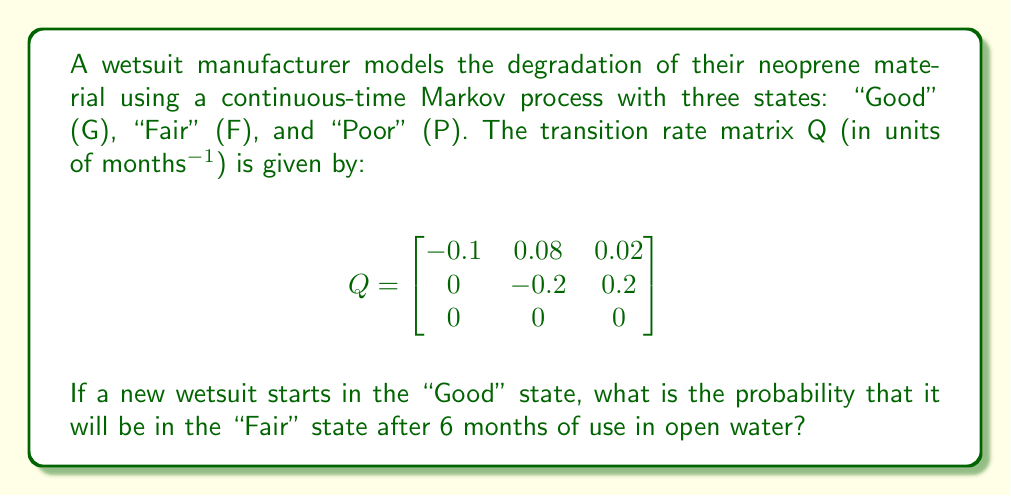Provide a solution to this math problem. To solve this problem, we need to use the continuous-time Markov process transition probability matrix, given by:

$$P(t) = e^{Qt}$$

Where $Q$ is the transition rate matrix and $t$ is the time (in this case, 6 months).

Steps to solve:

1) First, we need to calculate $e^{Qt}$. This can be done using the matrix exponential function or by utilizing eigenvalue decomposition.

2) For simplicity, we'll use a numerical approximation method:
   $$P(t) \approx I + Qt + \frac{(Qt)^2}{2!} + \frac{(Qt)^3}{3!} + ...$$

3) Let's calculate the first few terms:

   $Qt = 6 \cdot \begin{bmatrix}
   -0.1 & 0.08 & 0.02 \\
   0 & -0.2 & 0.2 \\
   0 & 0 & 0
   \end{bmatrix} = \begin{bmatrix}
   -0.6 & 0.48 & 0.12 \\
   0 & -1.2 & 1.2 \\
   0 & 0 & 0
   \end{bmatrix}$

   $(Qt)^2 = \begin{bmatrix}
   0.36 & -0.576 & 0.216 \\
   0 & 1.44 & -1.44 \\
   0 & 0 & 0
   \end{bmatrix}$

   $(Qt)^3 = \begin{bmatrix}
   -0.216 & 0.5184 & -0.3024 \\
   0 & -1.728 & 1.728 \\
   0 & 0 & 0
   \end{bmatrix}$

4) Now, let's sum up the terms:

   $P(6) \approx I + Qt + \frac{(Qt)^2}{2!} + \frac{(Qt)^3}{3!}$

   $\approx \begin{bmatrix}
   1 & 0 & 0 \\
   0 & 1 & 0 \\
   0 & 0 & 1
   \end{bmatrix} + \begin{bmatrix}
   -0.6 & 0.48 & 0.12 \\
   0 & -1.2 & 1.2 \\
   0 & 0 & 0
   \end{bmatrix} + \frac{1}{2}\begin{bmatrix}
   0.36 & -0.576 & 0.216 \\
   0 & 1.44 & -1.44 \\
   0 & 0 & 0
   \end{bmatrix} + \frac{1}{6}\begin{bmatrix}
   -0.216 & 0.5184 & -0.3024 \\
   0 & -1.728 & 1.728 \\
   0 & 0 & 0
   \end{bmatrix}$

5) Summing these matrices gives us the approximate transition probability matrix:

   $P(6) \approx \begin{bmatrix}
   0.5770 & 0.3389 & 0.0841 \\
   0 & 0.3012 & 0.6988 \\
   0 & 0 & 1
   \end{bmatrix}$

6) The probability of transitioning from "Good" to "Fair" after 6 months is given by the element in the first row, second column of this matrix.

Therefore, the probability that the wetsuit will be in the "Fair" state after 6 months, given that it started in the "Good" state, is approximately 0.3389 or 33.89%.
Answer: 0.3389 